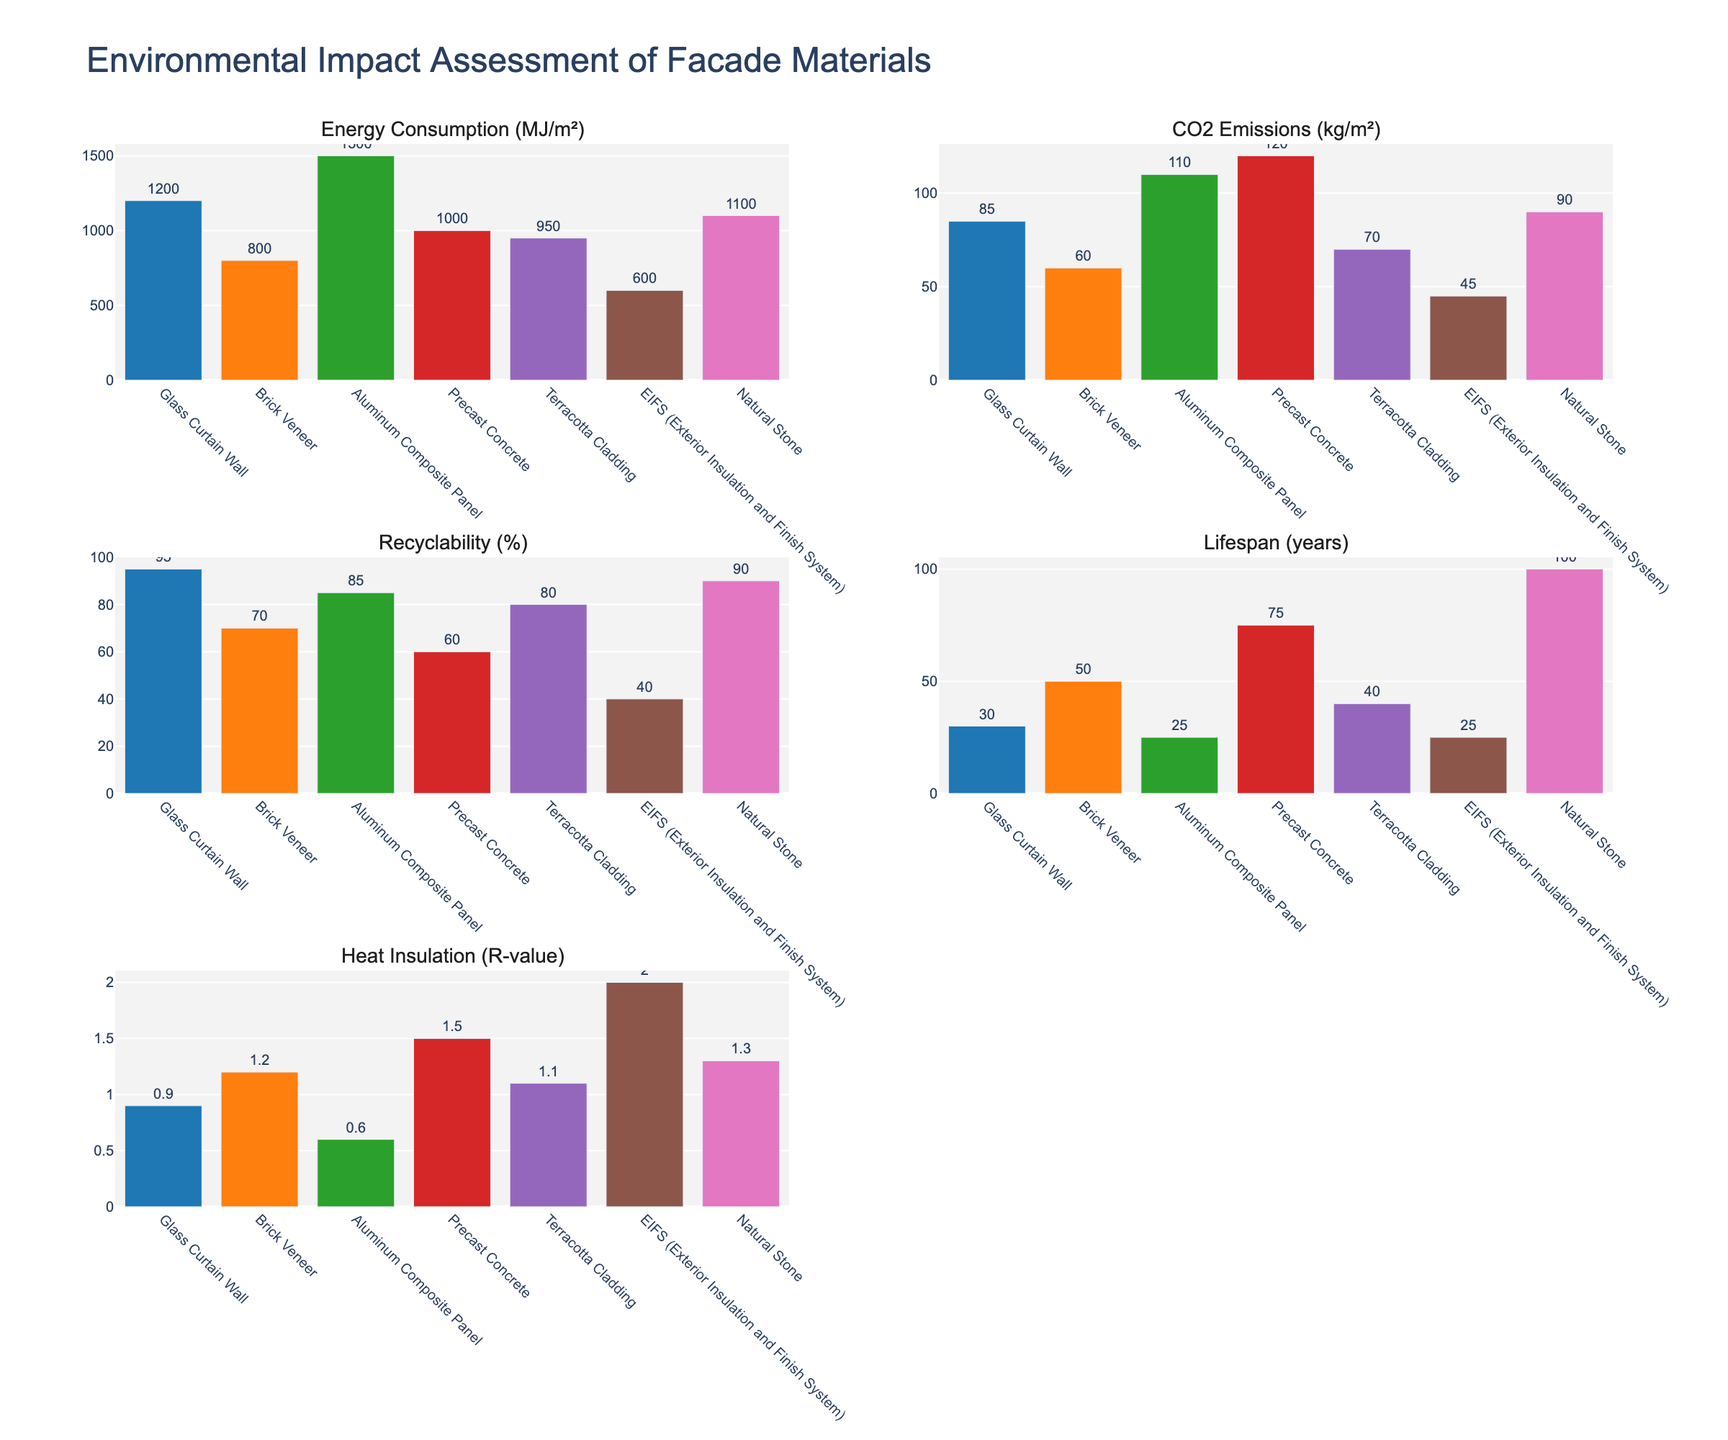what is the title of the plot? The title of the plot can be seen at the top of the figure where it is indicated prominently to describe the overall subject of the charts.
Answer: Environmental Impact Assessment of Facade Materials how many materials are assessed in the plot? Count the distinct items listed on the x-axis of each bar chart. Each axis will show the same set of materials.
Answer: 7 which material has the highest energy consumption? Look at the bar chart titled 'Energy Consumption (MJ/m²)' and find the bar with the greatest height. This bar corresponds to the material with the highest energy consumption.
Answer: Aluminum Composite Panel what is the difference in lifespan between terracotta cladding and eifs (exterior insulation and finish system)? Identify the bars corresponding to 'Terracotta Cladding' and 'EIFS (Exterior Insulation and Finish System)' in the 'Lifespan (years)' chart. Then, subtract the value of EIFS from the value of Terracotta Cladding.
Answer: 15 years what's the common characteristic with the highest value among all the materials? Examine each subplot chart and identify the characteristic where any material's bar reaches the maximum relative height.
Answer: Lifespan (years) which material has the lowest co2 emissions? Look at the 'CO2 Emissions (kg/m²)' bar chart and identify the shortest bar. Note the corresponding material.
Answer: EIFS (Exterior Insulation and Finish System) what is the average recyclability percentage of all materials? Add all the recyclability percentages from the 'Recyclability (%)' bar chart and divide by the number of materials.
Answer: (95+70+85+60+80+40+90)/7 = 74.3% how does the heat insulation (r-value) of natural stone compare to that of glass curtain wall? Look at the 'Heat Insulation (R-value)' bar chart and compare the heights of the bars for 'Natural Stone' and 'Glass Curtain Wall'. The taller bar indicates better insulation.
Answer: Natural Stone has higher R-value which material has the longest lifespan? Look at the bar chart titled 'Lifespan (years)' and identify the material corresponding to the tallest bar.
Answer: Natural Stone which characteristic shows the most variability across the materials? Examine the range and distribution of values in each bar chart. The chart with the greatest spread between the highest and lowest values indicates the most variability.
Answer: Lifespan (years) 